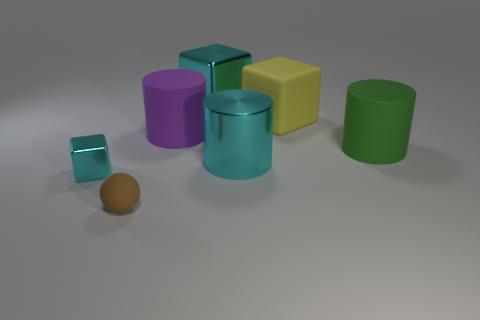Add 2 green matte cylinders. How many objects exist? 9 Subtract all cylinders. How many objects are left? 4 Subtract all small blue matte cylinders. Subtract all big green rubber things. How many objects are left? 6 Add 3 green things. How many green things are left? 4 Add 5 purple shiny cubes. How many purple shiny cubes exist? 5 Subtract 0 red spheres. How many objects are left? 7 